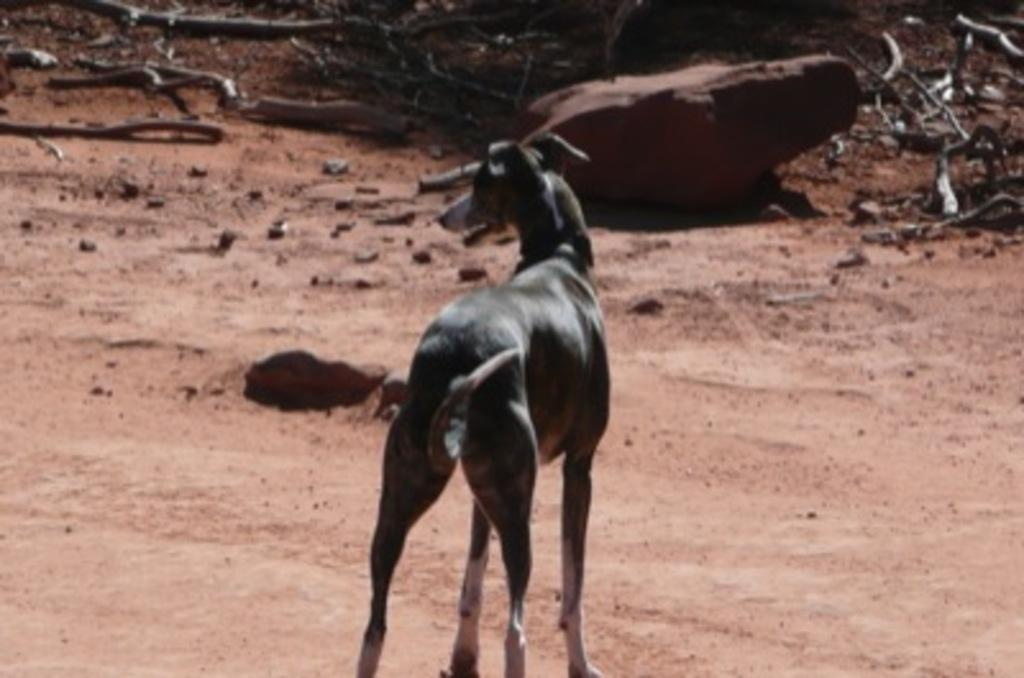What is the main subject in the center of the image? There is a dog in the center of the image. What can be seen on the floor in the background? There are wooden logs on the floor in the background. What type of material is the stone in the background made of? The stone in the background is made of stone. What historical event is depicted in the image? There is no historical event depicted in the image; it features a dog, wooden logs, and a stone. How many legs does the dog have in the image? The dog has four legs in the image. 